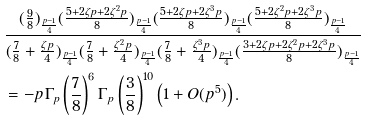Convert formula to latex. <formula><loc_0><loc_0><loc_500><loc_500>& \frac { ( \frac { 9 } { 8 } ) _ { \frac { p - 1 } { 4 } } ( \frac { 5 + 2 \zeta p + 2 \zeta ^ { 2 } p } { 8 } ) _ { \frac { p - 1 } { 4 } } ( \frac { 5 + 2 \zeta p + 2 \zeta ^ { 3 } p } { 8 } ) _ { \frac { p - 1 } { 4 } } ( \frac { 5 + 2 \zeta ^ { 2 } p + 2 \zeta ^ { 3 } p } { 8 } ) _ { \frac { p - 1 } { 4 } } } { ( \frac { 7 } { 8 } + \frac { \zeta p } { 4 } ) _ { \frac { p - 1 } { 4 } } ( \frac { 7 } { 8 } + \frac { \zeta ^ { 2 } p } { 4 } ) _ { \frac { p - 1 } { 4 } } ( \frac { 7 } { 8 } + \frac { \zeta ^ { 3 } p } { 4 } ) _ { \frac { p - 1 } { 4 } } ( \frac { 3 + 2 \zeta p + 2 \zeta ^ { 2 } p + 2 \zeta ^ { 3 } p } { 8 } ) _ { \frac { p - 1 } { 4 } } } \\ & = - p \Gamma _ { p } \left ( \frac { 7 } { 8 } \right ) ^ { 6 } \Gamma _ { p } \left ( \frac { 3 } { 8 } \right ) ^ { 1 0 } \left ( 1 + O ( p ^ { 5 } ) \right ) .</formula> 